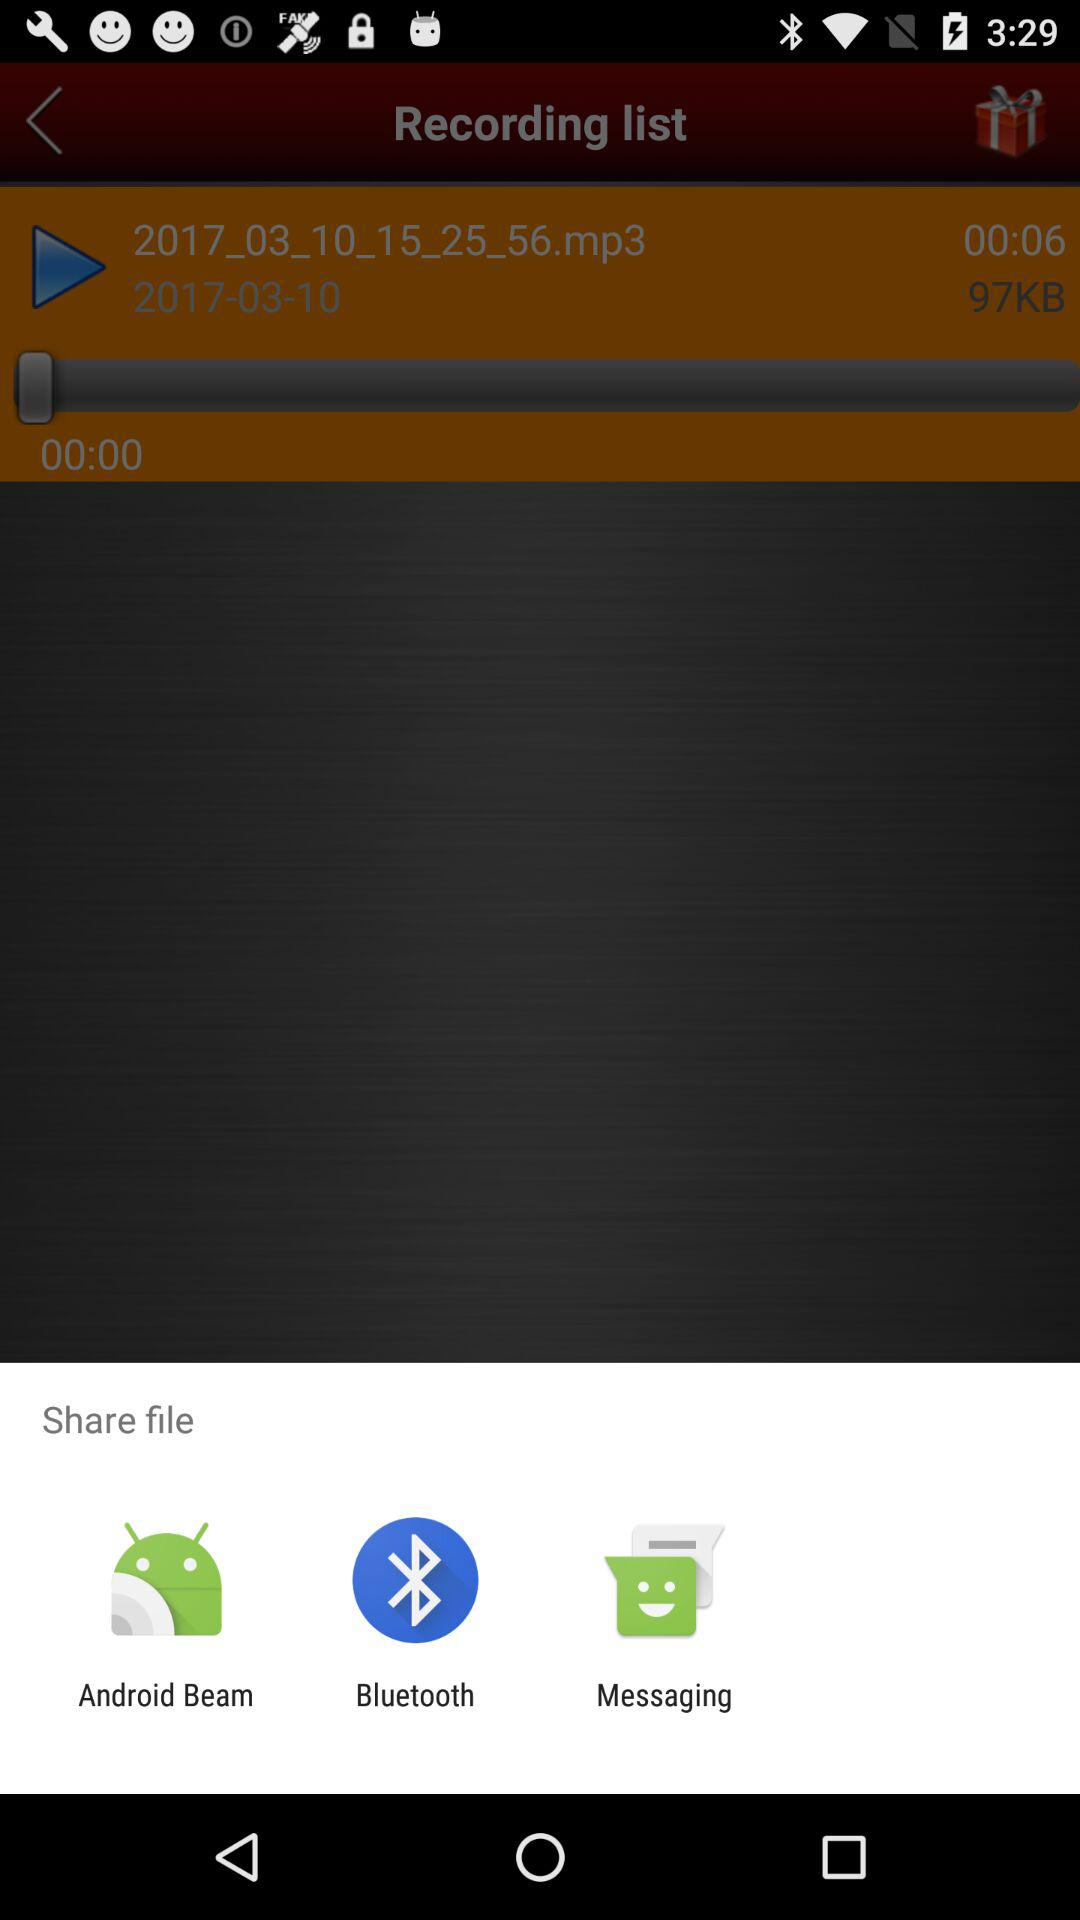What applications can be used to share? The applications are "Android Beam", "Bluetooth", and "Messaging" that can be used to share. 